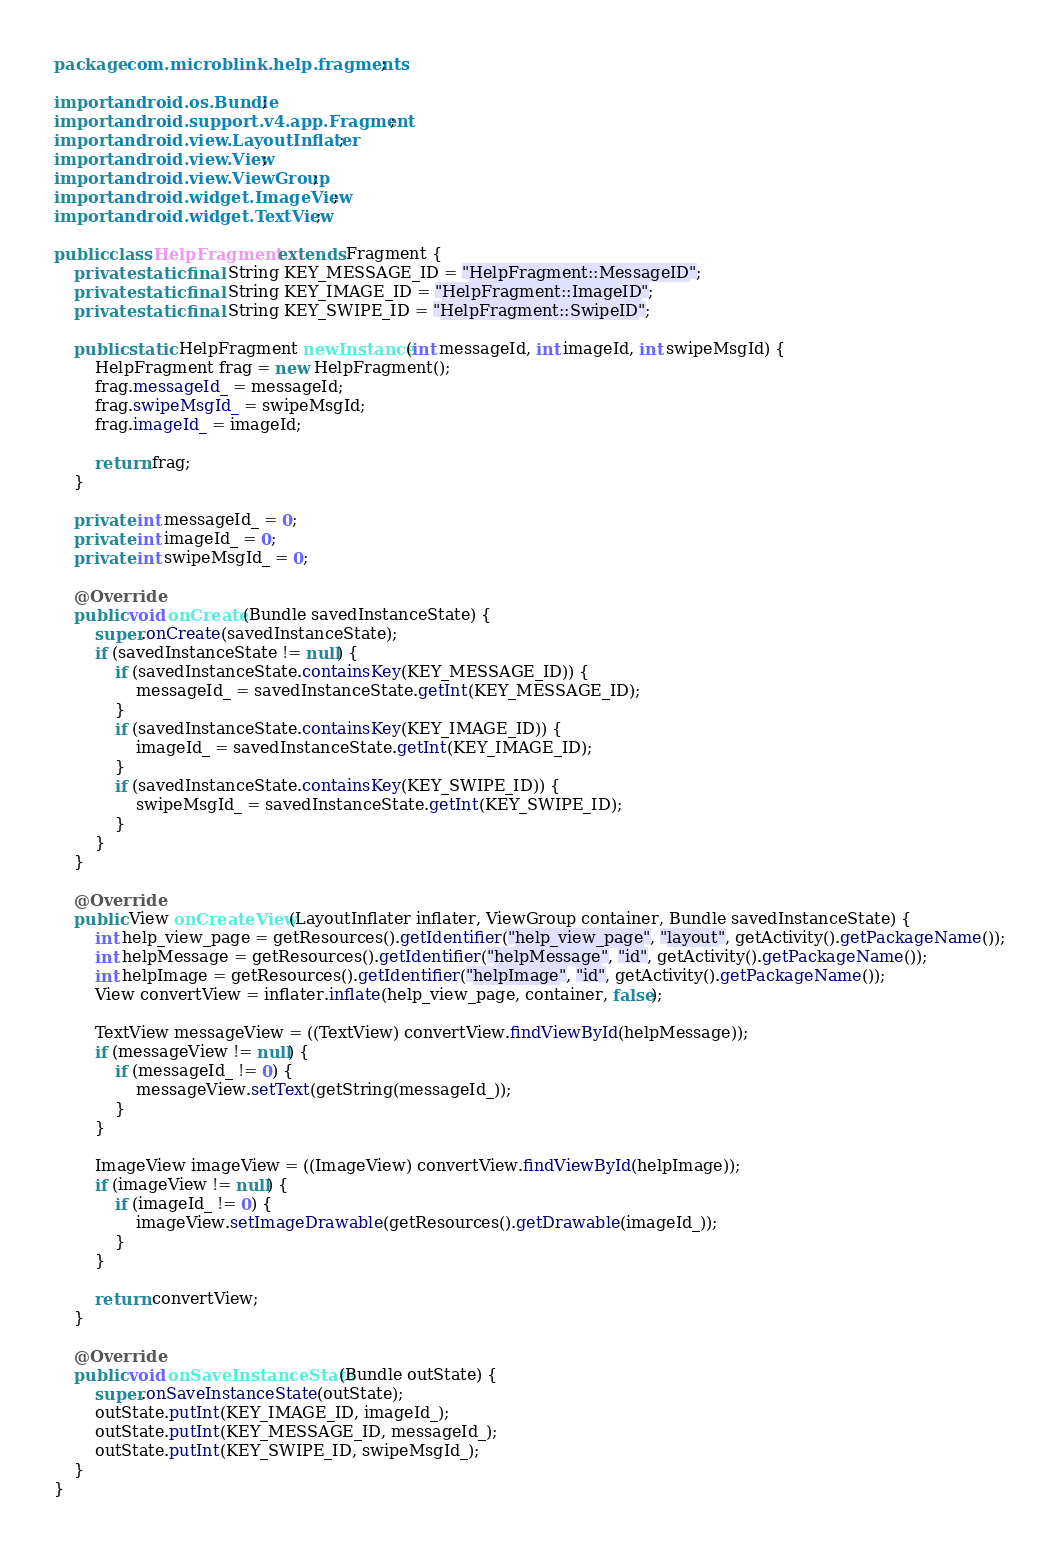Convert code to text. <code><loc_0><loc_0><loc_500><loc_500><_Java_>package com.microblink.help.fragments;

import android.os.Bundle;
import android.support.v4.app.Fragment;
import android.view.LayoutInflater;
import android.view.View;
import android.view.ViewGroup;
import android.widget.ImageView;
import android.widget.TextView;

public class HelpFragment extends Fragment {
    private static final String KEY_MESSAGE_ID = "HelpFragment::MessageID";
    private static final String KEY_IMAGE_ID = "HelpFragment::ImageID";
    private static final String KEY_SWIPE_ID = "HelpFragment::SwipeID";

    public static HelpFragment newInstance(int messageId, int imageId, int swipeMsgId) {
        HelpFragment frag = new HelpFragment();
        frag.messageId_ = messageId;
        frag.swipeMsgId_ = swipeMsgId;
        frag.imageId_ = imageId;

        return frag;
    }

    private int messageId_ = 0;
    private int imageId_ = 0;
    private int swipeMsgId_ = 0;

    @Override
    public void onCreate(Bundle savedInstanceState) {
        super.onCreate(savedInstanceState);
        if (savedInstanceState != null) {
            if (savedInstanceState.containsKey(KEY_MESSAGE_ID)) {
                messageId_ = savedInstanceState.getInt(KEY_MESSAGE_ID);
            }
            if (savedInstanceState.containsKey(KEY_IMAGE_ID)) {
                imageId_ = savedInstanceState.getInt(KEY_IMAGE_ID);
            }
            if (savedInstanceState.containsKey(KEY_SWIPE_ID)) {
                swipeMsgId_ = savedInstanceState.getInt(KEY_SWIPE_ID);
            }
        }
    }

    @Override
    public View onCreateView(LayoutInflater inflater, ViewGroup container, Bundle savedInstanceState) {
        int help_view_page = getResources().getIdentifier("help_view_page", "layout", getActivity().getPackageName());
        int helpMessage = getResources().getIdentifier("helpMessage", "id", getActivity().getPackageName());
        int helpImage = getResources().getIdentifier("helpImage", "id", getActivity().getPackageName());
        View convertView = inflater.inflate(help_view_page, container, false);

        TextView messageView = ((TextView) convertView.findViewById(helpMessage));
        if (messageView != null) {
            if (messageId_ != 0) {
                messageView.setText(getString(messageId_));
            }
        }

        ImageView imageView = ((ImageView) convertView.findViewById(helpImage));
        if (imageView != null) {
            if (imageId_ != 0) {
                imageView.setImageDrawable(getResources().getDrawable(imageId_));
            }
        }

        return convertView;
    }

    @Override
    public void onSaveInstanceState(Bundle outState) {
        super.onSaveInstanceState(outState);
        outState.putInt(KEY_IMAGE_ID, imageId_);
        outState.putInt(KEY_MESSAGE_ID, messageId_);
        outState.putInt(KEY_SWIPE_ID, swipeMsgId_);
    }
}
</code> 